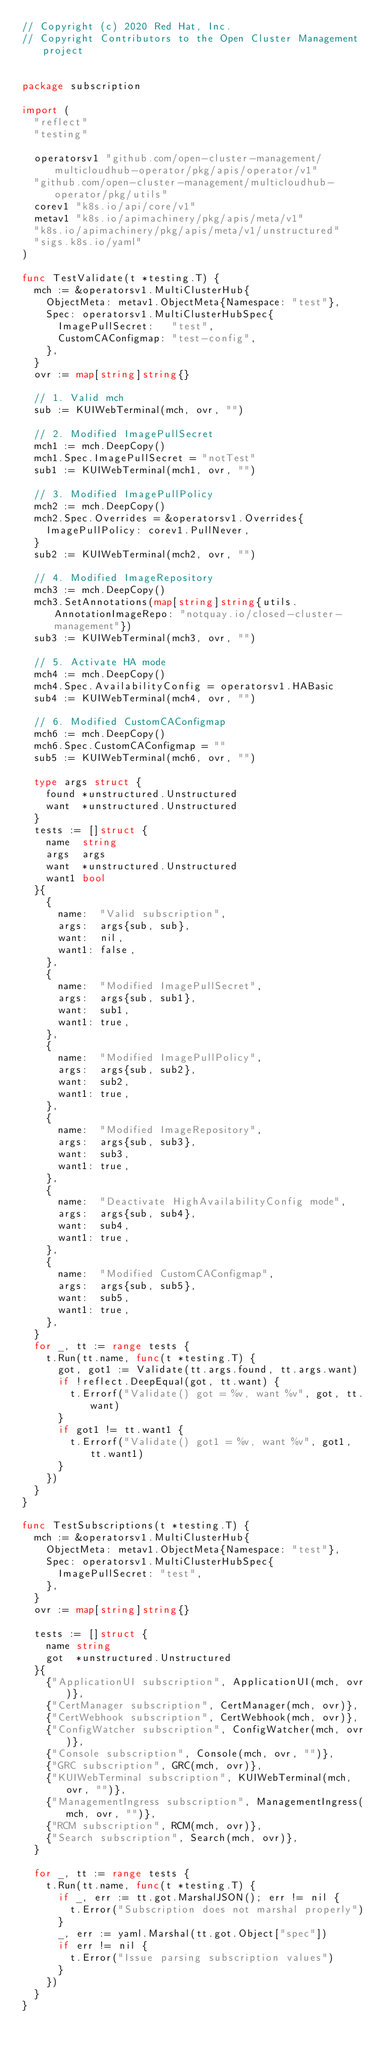<code> <loc_0><loc_0><loc_500><loc_500><_Go_>// Copyright (c) 2020 Red Hat, Inc.
// Copyright Contributors to the Open Cluster Management project


package subscription

import (
	"reflect"
	"testing"

	operatorsv1 "github.com/open-cluster-management/multicloudhub-operator/pkg/apis/operator/v1"
	"github.com/open-cluster-management/multicloudhub-operator/pkg/utils"
	corev1 "k8s.io/api/core/v1"
	metav1 "k8s.io/apimachinery/pkg/apis/meta/v1"
	"k8s.io/apimachinery/pkg/apis/meta/v1/unstructured"
	"sigs.k8s.io/yaml"
)

func TestValidate(t *testing.T) {
	mch := &operatorsv1.MultiClusterHub{
		ObjectMeta: metav1.ObjectMeta{Namespace: "test"},
		Spec: operatorsv1.MultiClusterHubSpec{
			ImagePullSecret:   "test",
			CustomCAConfigmap: "test-config",
		},
	}
	ovr := map[string]string{}

	// 1. Valid mch
	sub := KUIWebTerminal(mch, ovr, "")

	// 2. Modified ImagePullSecret
	mch1 := mch.DeepCopy()
	mch1.Spec.ImagePullSecret = "notTest"
	sub1 := KUIWebTerminal(mch1, ovr, "")

	// 3. Modified ImagePullPolicy
	mch2 := mch.DeepCopy()
	mch2.Spec.Overrides = &operatorsv1.Overrides{
		ImagePullPolicy: corev1.PullNever,
	}
	sub2 := KUIWebTerminal(mch2, ovr, "")

	// 4. Modified ImageRepository
	mch3 := mch.DeepCopy()
	mch3.SetAnnotations(map[string]string{utils.AnnotationImageRepo: "notquay.io/closed-cluster-management"})
	sub3 := KUIWebTerminal(mch3, ovr, "")

	// 5. Activate HA mode
	mch4 := mch.DeepCopy()
	mch4.Spec.AvailabilityConfig = operatorsv1.HABasic
	sub4 := KUIWebTerminal(mch4, ovr, "")

	// 6. Modified CustomCAConfigmap
	mch6 := mch.DeepCopy()
	mch6.Spec.CustomCAConfigmap = ""
	sub5 := KUIWebTerminal(mch6, ovr, "")

	type args struct {
		found *unstructured.Unstructured
		want  *unstructured.Unstructured
	}
	tests := []struct {
		name  string
		args  args
		want  *unstructured.Unstructured
		want1 bool
	}{
		{
			name:  "Valid subscription",
			args:  args{sub, sub},
			want:  nil,
			want1: false,
		},
		{
			name:  "Modified ImagePullSecret",
			args:  args{sub, sub1},
			want:  sub1,
			want1: true,
		},
		{
			name:  "Modified ImagePullPolicy",
			args:  args{sub, sub2},
			want:  sub2,
			want1: true,
		},
		{
			name:  "Modified ImageRepository",
			args:  args{sub, sub3},
			want:  sub3,
			want1: true,
		},
		{
			name:  "Deactivate HighAvailabilityConfig mode",
			args:  args{sub, sub4},
			want:  sub4,
			want1: true,
		},
		{
			name:  "Modified CustomCAConfigmap",
			args:  args{sub, sub5},
			want:  sub5,
			want1: true,
		},
	}
	for _, tt := range tests {
		t.Run(tt.name, func(t *testing.T) {
			got, got1 := Validate(tt.args.found, tt.args.want)
			if !reflect.DeepEqual(got, tt.want) {
				t.Errorf("Validate() got = %v, want %v", got, tt.want)
			}
			if got1 != tt.want1 {
				t.Errorf("Validate() got1 = %v, want %v", got1, tt.want1)
			}
		})
	}
}

func TestSubscriptions(t *testing.T) {
	mch := &operatorsv1.MultiClusterHub{
		ObjectMeta: metav1.ObjectMeta{Namespace: "test"},
		Spec: operatorsv1.MultiClusterHubSpec{
			ImagePullSecret: "test",
		},
	}
	ovr := map[string]string{}

	tests := []struct {
		name string
		got  *unstructured.Unstructured
	}{
		{"ApplicationUI subscription", ApplicationUI(mch, ovr)},
		{"CertManager subscription", CertManager(mch, ovr)},
		{"CertWebhook subscription", CertWebhook(mch, ovr)},
		{"ConfigWatcher subscription", ConfigWatcher(mch, ovr)},
		{"Console subscription", Console(mch, ovr, "")},
		{"GRC subscription", GRC(mch, ovr)},
		{"KUIWebTerminal subscription", KUIWebTerminal(mch, ovr, "")},
		{"ManagementIngress subscription", ManagementIngress(mch, ovr, "")},
		{"RCM subscription", RCM(mch, ovr)},
		{"Search subscription", Search(mch, ovr)},
	}

	for _, tt := range tests {
		t.Run(tt.name, func(t *testing.T) {
			if _, err := tt.got.MarshalJSON(); err != nil {
				t.Error("Subscription does not marshal properly")
			}
			_, err := yaml.Marshal(tt.got.Object["spec"])
			if err != nil {
				t.Error("Issue parsing subscription values")
			}
		})
	}
}
</code> 